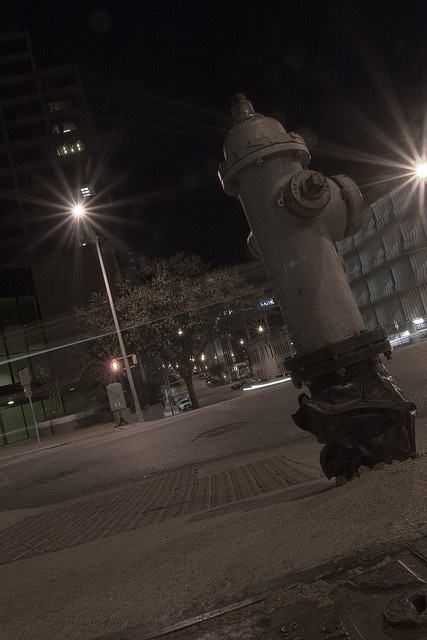Describe the objects in this image and their specific colors. I can see fire hydrant in black and gray tones, car in black and gray tones, car in black and gray tones, and car in black and gray tones in this image. 